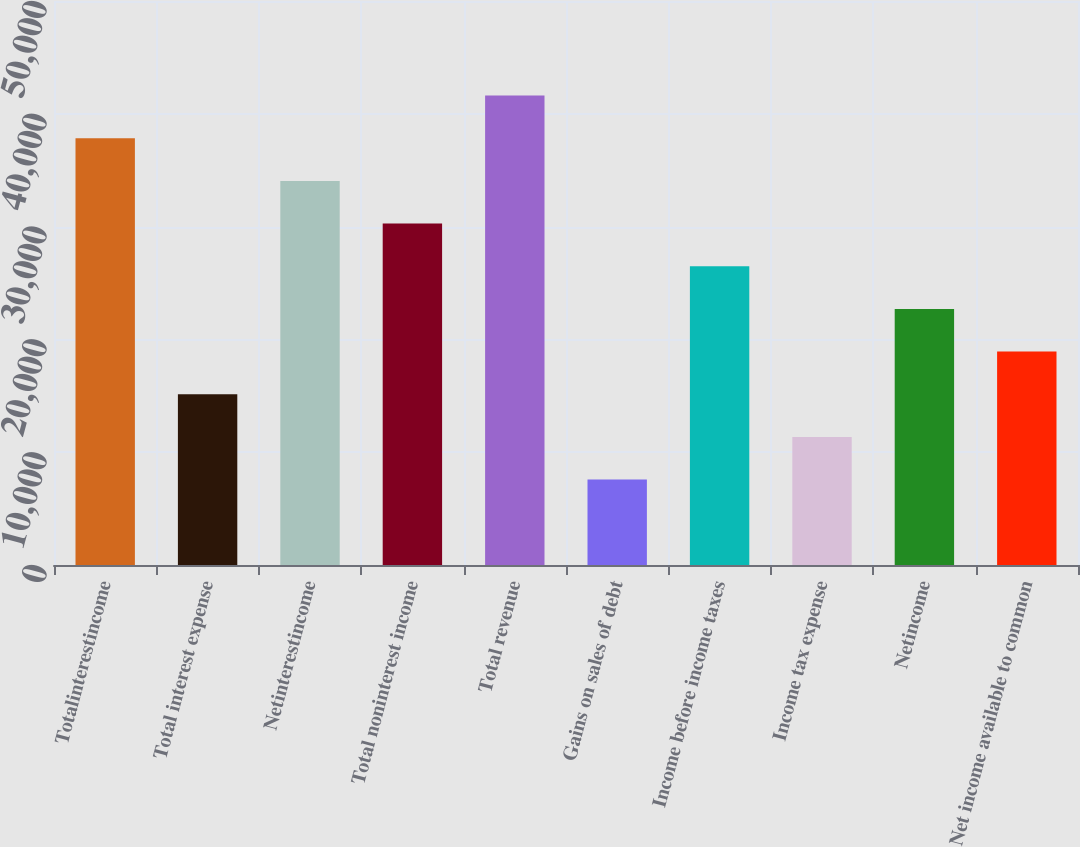<chart> <loc_0><loc_0><loc_500><loc_500><bar_chart><fcel>Totalinterestincome<fcel>Total interest expense<fcel>Netinterestincome<fcel>Total noninterest income<fcel>Total revenue<fcel>Gains on sales of debt<fcel>Income before income taxes<fcel>Income tax expense<fcel>Netincome<fcel>Net income available to common<nl><fcel>37834<fcel>15135.7<fcel>34050.9<fcel>30267.9<fcel>41617<fcel>7569.65<fcel>26484.9<fcel>11352.7<fcel>22701.8<fcel>18918.8<nl></chart> 